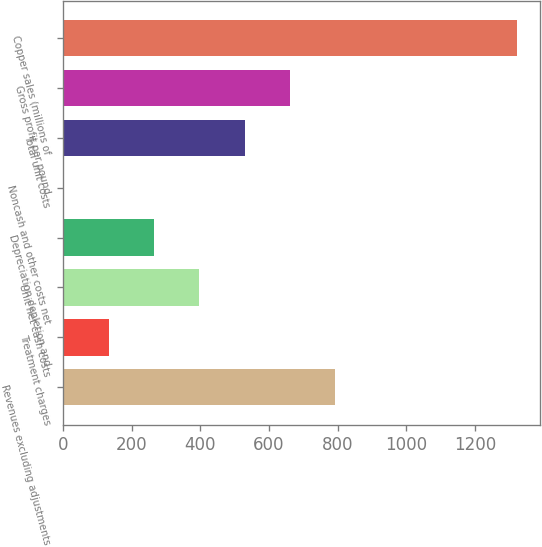Convert chart. <chart><loc_0><loc_0><loc_500><loc_500><bar_chart><fcel>Revenues excluding adjustments<fcel>Treatment charges<fcel>Unit net cash costs<fcel>Depreciation depletion and<fcel>Noncash and other costs net<fcel>Total unit costs<fcel>Gross profit per pound<fcel>Copper sales (millions of<nl><fcel>793.24<fcel>132.25<fcel>396.64<fcel>264.45<fcel>0.05<fcel>528.84<fcel>661.04<fcel>1322<nl></chart> 